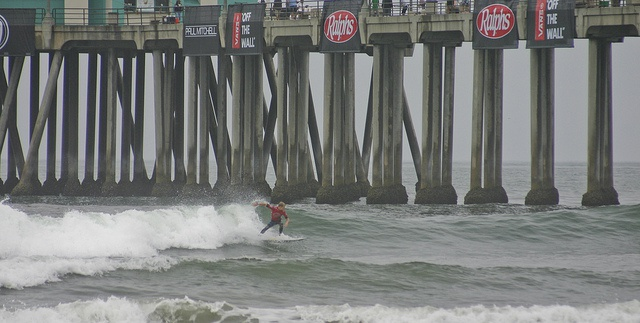Describe the objects in this image and their specific colors. I can see people in teal, gray, brown, and darkgray tones, people in teal, gray, darkgray, and black tones, people in teal, gray, and black tones, surfboard in teal, darkgray, and gray tones, and people in teal, gray, and black tones in this image. 